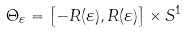<formula> <loc_0><loc_0><loc_500><loc_500>\Theta _ { \varepsilon } = \left [ - R ( \varepsilon ) , R ( \varepsilon ) \right ] \times S ^ { 1 }</formula> 